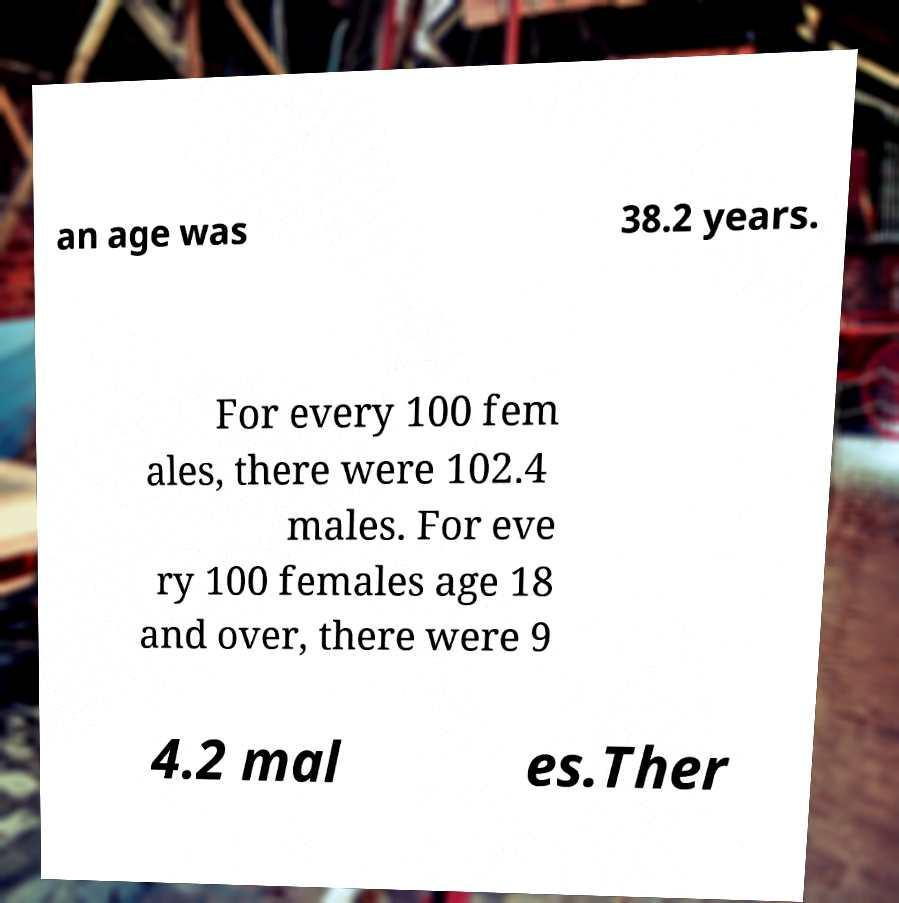Can you accurately transcribe the text from the provided image for me? an age was 38.2 years. For every 100 fem ales, there were 102.4 males. For eve ry 100 females age 18 and over, there were 9 4.2 mal es.Ther 